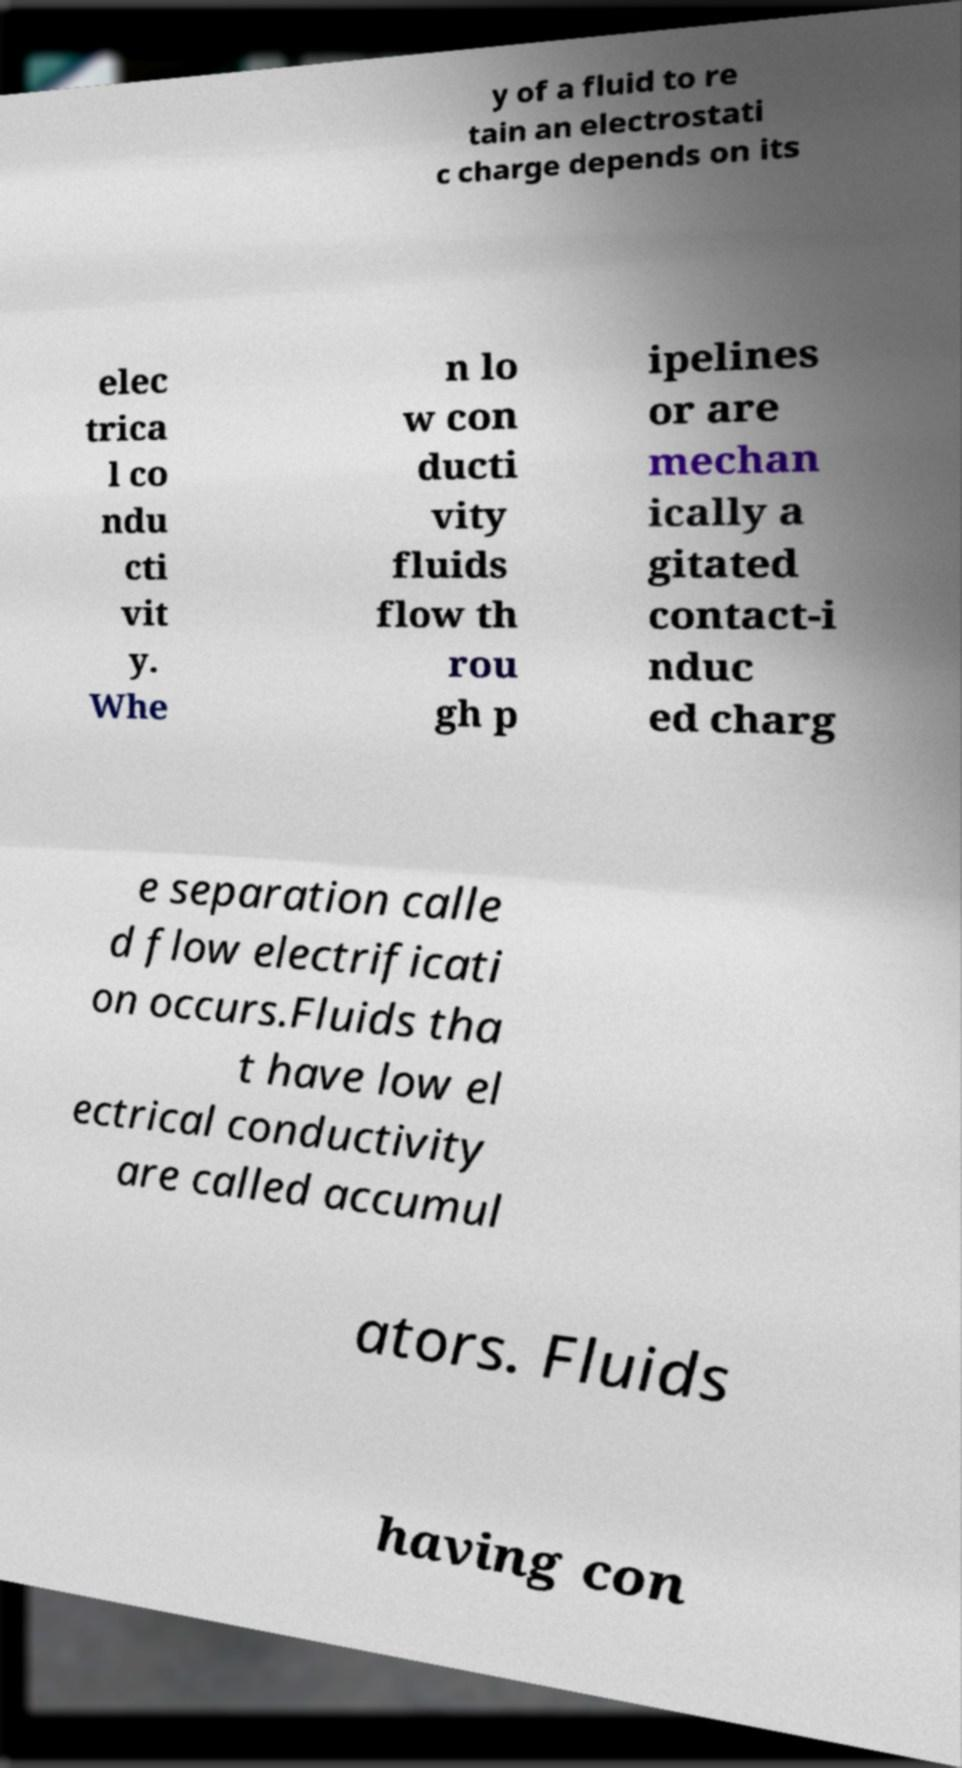For documentation purposes, I need the text within this image transcribed. Could you provide that? y of a fluid to re tain an electrostati c charge depends on its elec trica l co ndu cti vit y. Whe n lo w con ducti vity fluids flow th rou gh p ipelines or are mechan ically a gitated contact-i nduc ed charg e separation calle d flow electrificati on occurs.Fluids tha t have low el ectrical conductivity are called accumul ators. Fluids having con 